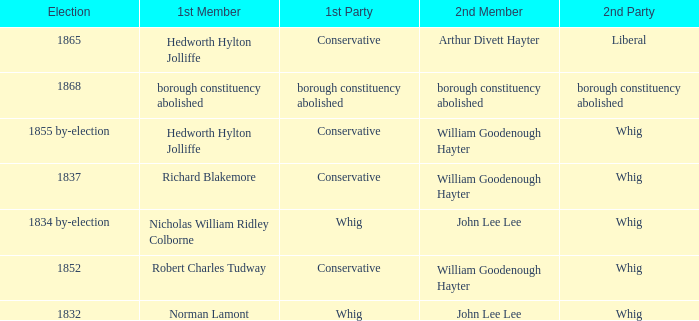Who's the conservative 1st member of the election of 1852? Robert Charles Tudway. 